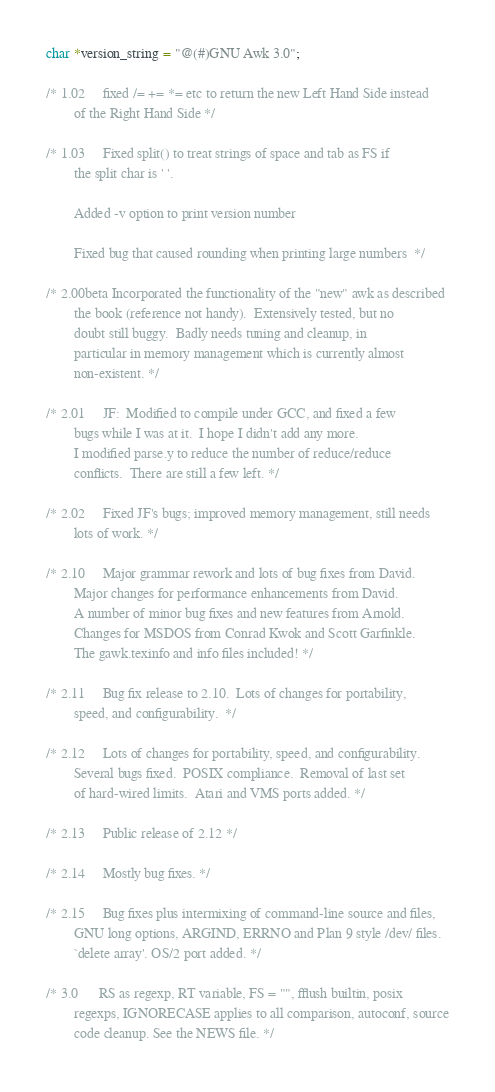<code> <loc_0><loc_0><loc_500><loc_500><_C_>char *version_string = "@(#)GNU Awk 3.0";

/* 1.02		fixed /= += *= etc to return the new Left Hand Side instead
		of the Right Hand Side */

/* 1.03		Fixed split() to treat strings of space and tab as FS if
		the split char is ' '.

		Added -v option to print version number
 		
		Fixed bug that caused rounding when printing large numbers  */

/* 2.00beta	Incorporated the functionality of the "new" awk as described
		the book (reference not handy).  Extensively tested, but no 
		doubt still buggy.  Badly needs tuning and cleanup, in
		particular in memory management which is currently almost
		non-existent. */

/* 2.01		JF:  Modified to compile under GCC, and fixed a few
		bugs while I was at it.  I hope I didn't add any more.
		I modified parse.y to reduce the number of reduce/reduce
		conflicts.  There are still a few left. */

/* 2.02		Fixed JF's bugs; improved memory management, still needs
		lots of work. */

/* 2.10		Major grammar rework and lots of bug fixes from David.
		Major changes for performance enhancements from David.
		A number of minor bug fixes and new features from Arnold.
		Changes for MSDOS from Conrad Kwok and Scott Garfinkle.
		The gawk.texinfo and info files included! */

/* 2.11		Bug fix release to 2.10.  Lots of changes for portability,
		speed, and configurability.  */

/* 2.12		Lots of changes for portability, speed, and configurability.
		Several bugs fixed.  POSIX compliance.  Removal of last set
		of hard-wired limits.  Atari and VMS ports added. */

/* 2.13		Public release of 2.12 */

/* 2.14		Mostly bug fixes. */

/* 2.15		Bug fixes plus intermixing of command-line source and files,
		GNU long options, ARGIND, ERRNO and Plan 9 style /dev/ files.
		`delete array'. OS/2 port added. */

/* 3.0		RS as regexp, RT variable, FS = "", fflush builtin, posix
		regexps, IGNORECASE applies to all comparison, autoconf, source
		code cleanup. See the NEWS file. */
</code> 